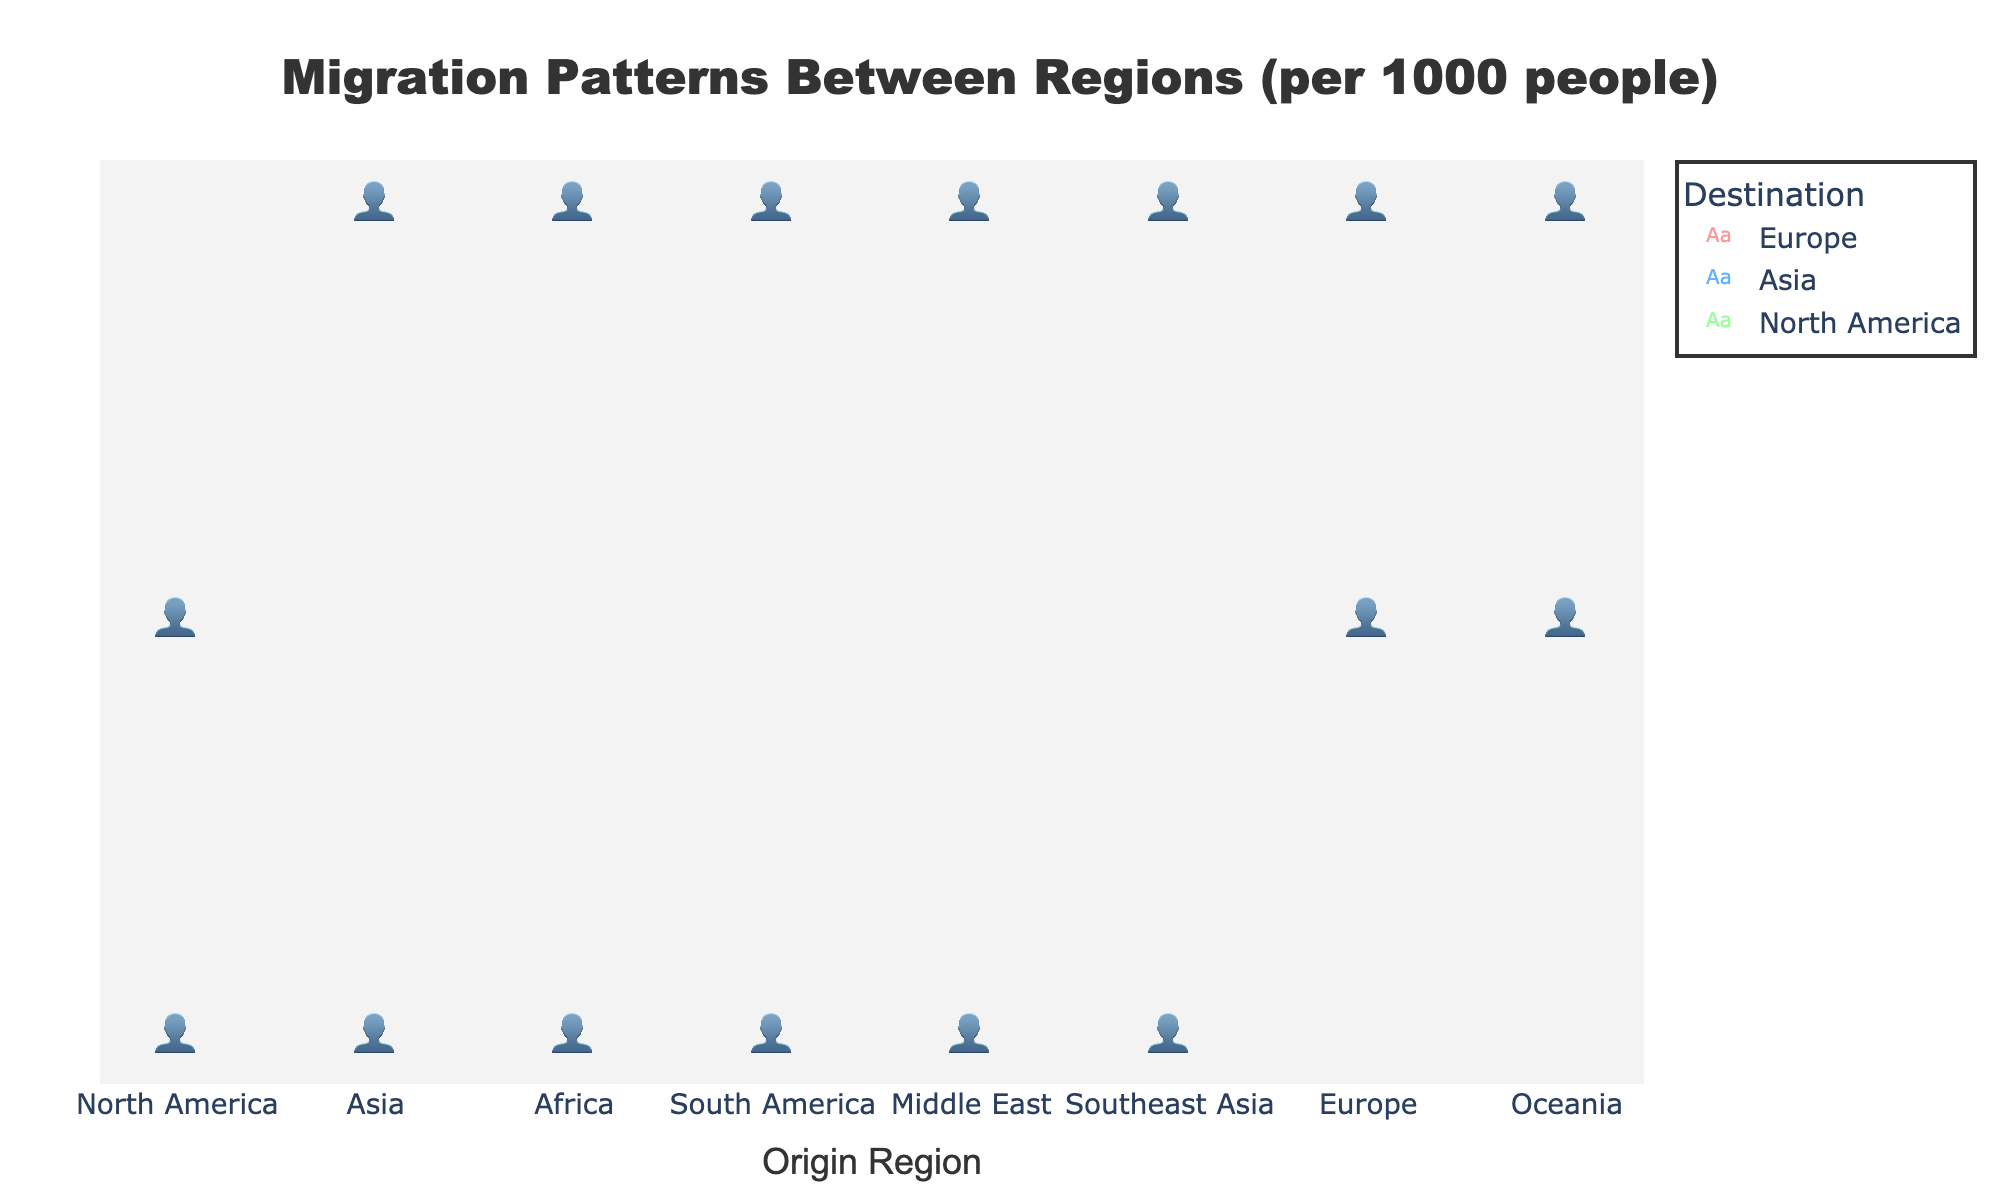Which origin region has the highest number of migrants per 1000 people moving to Europe? To find the origin region with the highest number of migrants per 1000 people moving to Europe, look at the height of the bars representing Europe. Africa has the tallest bar, indicating 8 migrants per 1000 people.
Answer: Africa Which destination region receives the highest number of migrants from Asia? Locate the 'Asia' region and observe the height of the bars (isotypes) for each destination region. North America has the highest bar for Asia, indicating 6 migrants per 1000 people.
Answer: North America Compare the number of migrants per 1000 people from South America to North America and Europe. Which destination is higher? Evaluate the heights of the bars originating from South America. The bar to North America represents 7 migrants per 1000 people, while the bar to Europe represents 4 migrants per 1000 people. North America is higher.
Answer: North America How many migrants per 1000 people move from Oceania to North America and Asia combined? Find the two bars originating from Oceania. The bar to North America is 2 migrants per 1000 people, and the bar to Asia is 3 migrants per 1000 people. Adding these together, 2 + 3 = 5.
Answer: 5 Which regions have exactly 3 migrants per 1000 people moving to North America? Look for the bars representing 3 migrants per 1000 people to North America. North America to Asia, Africa, Middle East, and Oceania each have 3 migrants per 1000 people moving to North America.
Answer: Africa, Middle East, Oceania What is the average number of migrants per 1000 people moving from Africa to its destinations? Identify the bars originating from Africa. They are 8 migrants per 1000 people to Europe and 3 migrants per 1000 people to North America. The average is (8 + 3) / 2 = 5.5.
Answer: 5.5 Identify the two origin regions with the highest total number of migrants per 1000 people moving to all destinations. Sum the bars for each origin region. Africa has 8 (Europe) + 3 (North America) = 11. South America has 7 (North America) + 4 (Europe) = 11. No other regions have higher totals.
Answer: Africa, South America Which destination region receives the most migrants per 1000 people from the Middle East and Southeast Asia combined? Observe the bars for Middle East and Southeast Asia. The bars to Europe are 6 (Middle East) and 3 (Southeast Asia). The bars to North America are 3 (Middle East) and 5 (Southeast Asia), totaling 8 each. Equal for North America and Europe.
Answer: North America, Europe 